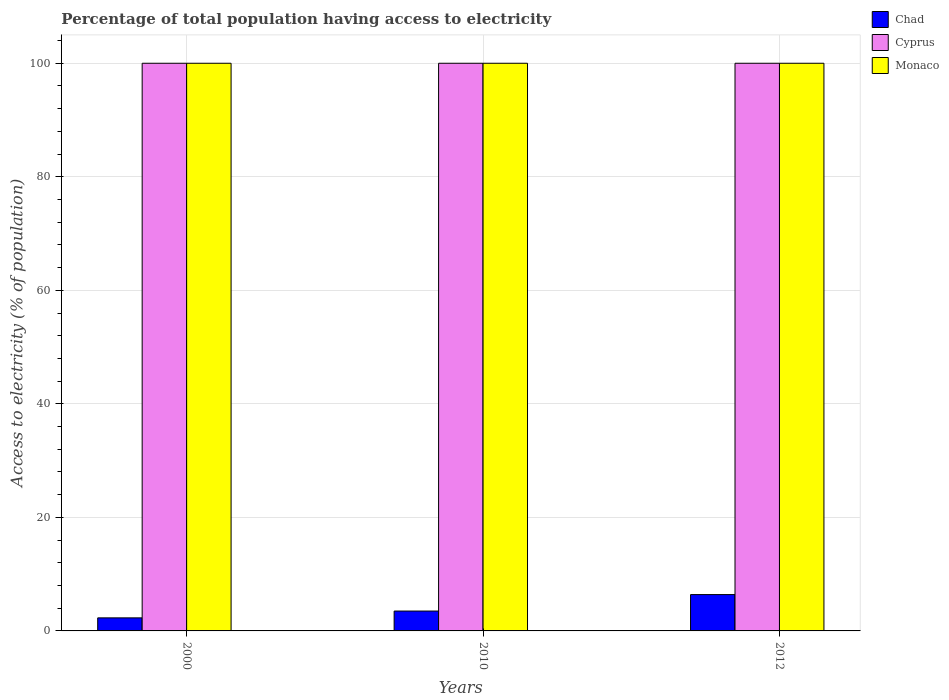How many bars are there on the 1st tick from the left?
Ensure brevity in your answer.  3. How many bars are there on the 3rd tick from the right?
Your response must be concise. 3. In how many cases, is the number of bars for a given year not equal to the number of legend labels?
Provide a short and direct response. 0. What is the percentage of population that have access to electricity in Cyprus in 2010?
Keep it short and to the point. 100. Across all years, what is the maximum percentage of population that have access to electricity in Cyprus?
Give a very brief answer. 100. In which year was the percentage of population that have access to electricity in Chad minimum?
Offer a terse response. 2000. What is the total percentage of population that have access to electricity in Cyprus in the graph?
Your answer should be compact. 300. What is the difference between the percentage of population that have access to electricity in Cyprus in 2000 and that in 2012?
Offer a terse response. 0. What is the difference between the percentage of population that have access to electricity in Chad in 2000 and the percentage of population that have access to electricity in Cyprus in 2012?
Ensure brevity in your answer.  -97.7. What is the average percentage of population that have access to electricity in Chad per year?
Provide a succinct answer. 4.07. In the year 2010, what is the difference between the percentage of population that have access to electricity in Cyprus and percentage of population that have access to electricity in Chad?
Offer a terse response. 96.5. Is the percentage of population that have access to electricity in Chad in 2000 less than that in 2010?
Offer a terse response. Yes. What is the difference between the highest and the lowest percentage of population that have access to electricity in Chad?
Keep it short and to the point. 4.1. Is the sum of the percentage of population that have access to electricity in Monaco in 2010 and 2012 greater than the maximum percentage of population that have access to electricity in Chad across all years?
Give a very brief answer. Yes. What does the 3rd bar from the left in 2000 represents?
Your answer should be compact. Monaco. What does the 2nd bar from the right in 2012 represents?
Ensure brevity in your answer.  Cyprus. Is it the case that in every year, the sum of the percentage of population that have access to electricity in Cyprus and percentage of population that have access to electricity in Chad is greater than the percentage of population that have access to electricity in Monaco?
Give a very brief answer. Yes. How many years are there in the graph?
Offer a terse response. 3. Does the graph contain any zero values?
Offer a very short reply. No. Where does the legend appear in the graph?
Offer a very short reply. Top right. What is the title of the graph?
Make the answer very short. Percentage of total population having access to electricity. What is the label or title of the Y-axis?
Keep it short and to the point. Access to electricity (% of population). What is the Access to electricity (% of population) in Monaco in 2000?
Provide a short and direct response. 100. What is the Access to electricity (% of population) of Chad in 2010?
Your answer should be very brief. 3.5. What is the Access to electricity (% of population) of Cyprus in 2010?
Make the answer very short. 100. What is the Access to electricity (% of population) of Monaco in 2010?
Give a very brief answer. 100. Across all years, what is the maximum Access to electricity (% of population) in Cyprus?
Your response must be concise. 100. Across all years, what is the minimum Access to electricity (% of population) in Chad?
Keep it short and to the point. 2.3. What is the total Access to electricity (% of population) in Chad in the graph?
Your answer should be compact. 12.2. What is the total Access to electricity (% of population) of Cyprus in the graph?
Provide a succinct answer. 300. What is the total Access to electricity (% of population) of Monaco in the graph?
Provide a short and direct response. 300. What is the difference between the Access to electricity (% of population) of Chad in 2000 and that in 2010?
Offer a terse response. -1.2. What is the difference between the Access to electricity (% of population) of Chad in 2000 and that in 2012?
Make the answer very short. -4.1. What is the difference between the Access to electricity (% of population) of Monaco in 2000 and that in 2012?
Your answer should be very brief. 0. What is the difference between the Access to electricity (% of population) of Chad in 2010 and that in 2012?
Offer a terse response. -2.9. What is the difference between the Access to electricity (% of population) of Chad in 2000 and the Access to electricity (% of population) of Cyprus in 2010?
Ensure brevity in your answer.  -97.7. What is the difference between the Access to electricity (% of population) in Chad in 2000 and the Access to electricity (% of population) in Monaco in 2010?
Ensure brevity in your answer.  -97.7. What is the difference between the Access to electricity (% of population) of Cyprus in 2000 and the Access to electricity (% of population) of Monaco in 2010?
Give a very brief answer. 0. What is the difference between the Access to electricity (% of population) of Chad in 2000 and the Access to electricity (% of population) of Cyprus in 2012?
Provide a succinct answer. -97.7. What is the difference between the Access to electricity (% of population) in Chad in 2000 and the Access to electricity (% of population) in Monaco in 2012?
Your answer should be compact. -97.7. What is the difference between the Access to electricity (% of population) in Cyprus in 2000 and the Access to electricity (% of population) in Monaco in 2012?
Your answer should be very brief. 0. What is the difference between the Access to electricity (% of population) in Chad in 2010 and the Access to electricity (% of population) in Cyprus in 2012?
Provide a short and direct response. -96.5. What is the difference between the Access to electricity (% of population) of Chad in 2010 and the Access to electricity (% of population) of Monaco in 2012?
Your answer should be very brief. -96.5. What is the difference between the Access to electricity (% of population) of Cyprus in 2010 and the Access to electricity (% of population) of Monaco in 2012?
Offer a terse response. 0. What is the average Access to electricity (% of population) in Chad per year?
Make the answer very short. 4.07. What is the average Access to electricity (% of population) in Cyprus per year?
Offer a very short reply. 100. In the year 2000, what is the difference between the Access to electricity (% of population) in Chad and Access to electricity (% of population) in Cyprus?
Offer a very short reply. -97.7. In the year 2000, what is the difference between the Access to electricity (% of population) in Chad and Access to electricity (% of population) in Monaco?
Provide a short and direct response. -97.7. In the year 2010, what is the difference between the Access to electricity (% of population) in Chad and Access to electricity (% of population) in Cyprus?
Your answer should be very brief. -96.5. In the year 2010, what is the difference between the Access to electricity (% of population) of Chad and Access to electricity (% of population) of Monaco?
Your response must be concise. -96.5. In the year 2010, what is the difference between the Access to electricity (% of population) of Cyprus and Access to electricity (% of population) of Monaco?
Make the answer very short. 0. In the year 2012, what is the difference between the Access to electricity (% of population) of Chad and Access to electricity (% of population) of Cyprus?
Provide a short and direct response. -93.6. In the year 2012, what is the difference between the Access to electricity (% of population) of Chad and Access to electricity (% of population) of Monaco?
Ensure brevity in your answer.  -93.6. In the year 2012, what is the difference between the Access to electricity (% of population) of Cyprus and Access to electricity (% of population) of Monaco?
Your answer should be compact. 0. What is the ratio of the Access to electricity (% of population) in Chad in 2000 to that in 2010?
Your answer should be compact. 0.66. What is the ratio of the Access to electricity (% of population) of Chad in 2000 to that in 2012?
Give a very brief answer. 0.36. What is the ratio of the Access to electricity (% of population) in Cyprus in 2000 to that in 2012?
Provide a succinct answer. 1. What is the ratio of the Access to electricity (% of population) of Monaco in 2000 to that in 2012?
Your answer should be compact. 1. What is the ratio of the Access to electricity (% of population) of Chad in 2010 to that in 2012?
Offer a very short reply. 0.55. What is the difference between the highest and the second highest Access to electricity (% of population) of Monaco?
Give a very brief answer. 0. What is the difference between the highest and the lowest Access to electricity (% of population) of Cyprus?
Offer a terse response. 0. What is the difference between the highest and the lowest Access to electricity (% of population) of Monaco?
Make the answer very short. 0. 